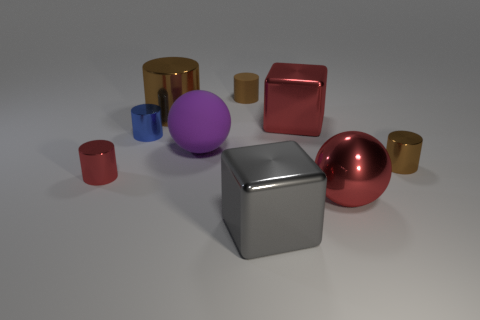Subtract 2 cylinders. How many cylinders are left? 3 Subtract all blue blocks. How many brown cylinders are left? 3 Subtract all blue cylinders. How many cylinders are left? 4 Subtract all blue cylinders. How many cylinders are left? 4 Subtract all yellow cylinders. Subtract all blue balls. How many cylinders are left? 5 Subtract all spheres. How many objects are left? 7 Add 2 large brown objects. How many large brown objects are left? 3 Add 9 gray metallic things. How many gray metallic things exist? 10 Subtract 0 cyan cubes. How many objects are left? 9 Subtract all big brown rubber things. Subtract all large gray blocks. How many objects are left? 8 